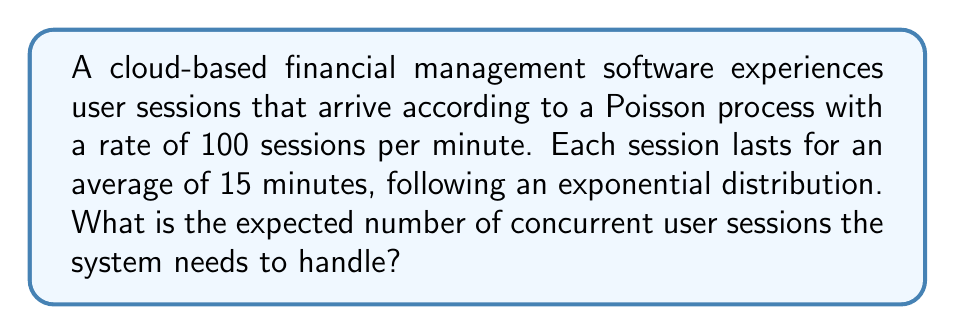Give your solution to this math problem. To solve this problem, we can use the M/M/∞ queueing model, where:
1. Arrivals follow a Poisson process (M)
2. Service times are exponentially distributed (M)
3. There are infinite servers (∞), meaning no queueing

Step 1: Identify the arrival rate (λ) and service rate (μ)
λ = 100 sessions/minute
μ = 1/15 sessions/minute (as average session duration is 15 minutes)

Step 2: Calculate the traffic intensity (ρ)
The traffic intensity ρ is given by:
$$\rho = \frac{\lambda}{\mu}$$

Substituting the values:
$$\rho = \frac{100}{1/15} = 100 \times 15 = 1500$$

Step 3: Determine the expected number of concurrent sessions
For an M/M/∞ queue, the expected number of customers in the system (L) is equal to the traffic intensity ρ:

$$L = \rho = 1500$$

Therefore, the expected number of concurrent user sessions the system needs to handle is 1500.
Answer: 1500 concurrent sessions 